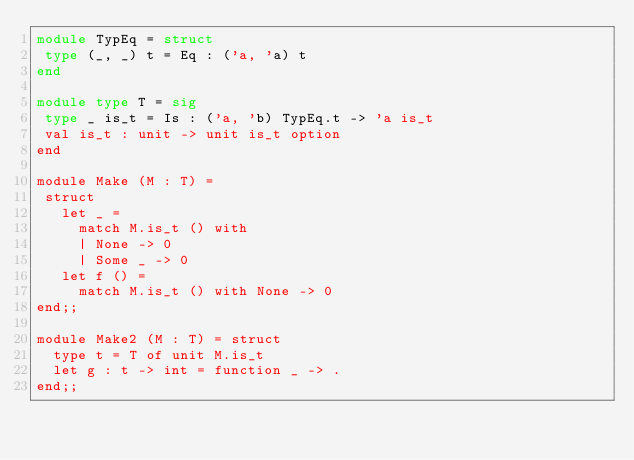<code> <loc_0><loc_0><loc_500><loc_500><_OCaml_>module TypEq = struct
 type (_, _) t = Eq : ('a, 'a) t
end

module type T = sig
 type _ is_t = Is : ('a, 'b) TypEq.t -> 'a is_t
 val is_t : unit -> unit is_t option
end

module Make (M : T) =
 struct
   let _ =
     match M.is_t () with
     | None -> 0
     | Some _ -> 0
   let f () =
     match M.is_t () with None -> 0
end;;

module Make2 (M : T) = struct
  type t = T of unit M.is_t
  let g : t -> int = function _ -> .
end;;
</code> 